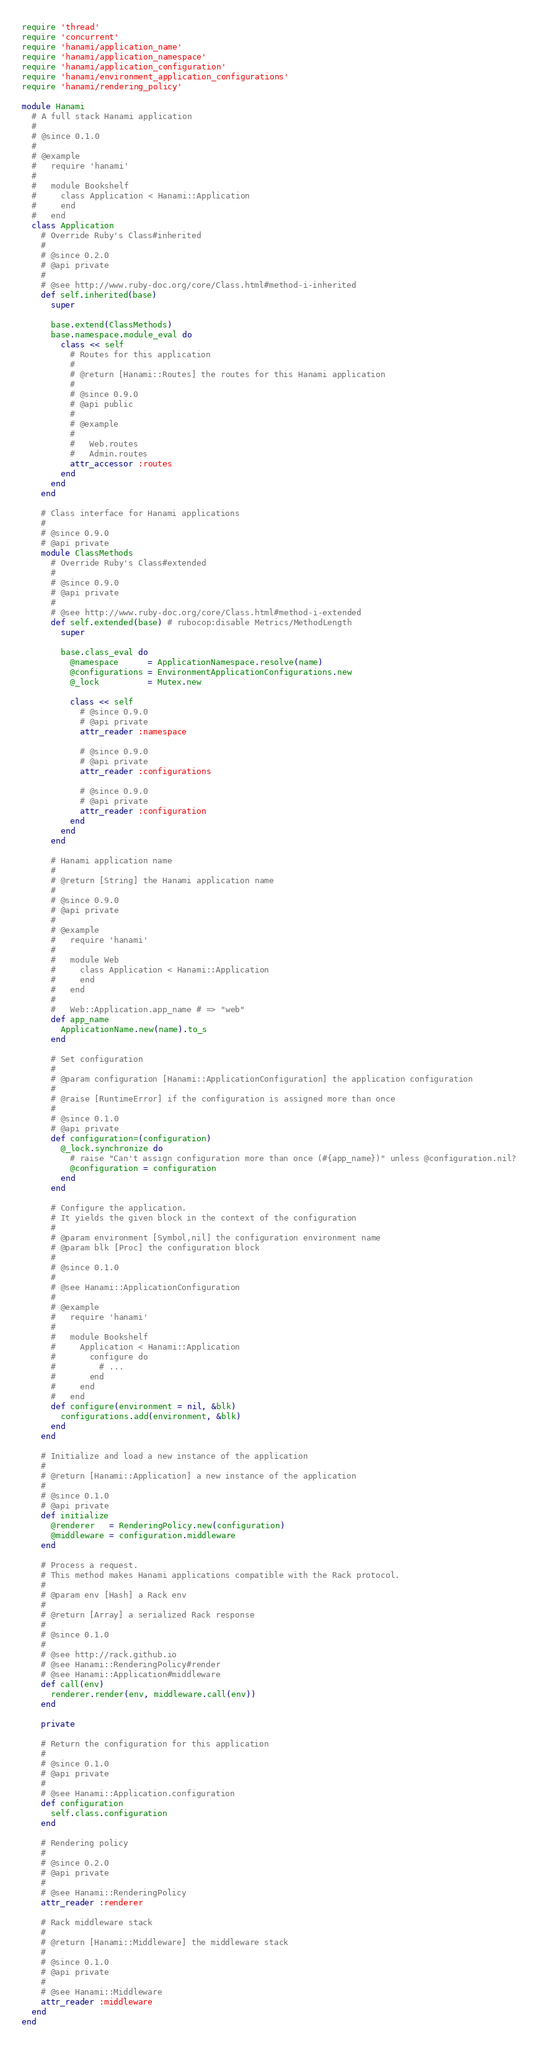Convert code to text. <code><loc_0><loc_0><loc_500><loc_500><_Ruby_>require 'thread'
require 'concurrent'
require 'hanami/application_name'
require 'hanami/application_namespace'
require 'hanami/application_configuration'
require 'hanami/environment_application_configurations'
require 'hanami/rendering_policy'

module Hanami
  # A full stack Hanami application
  #
  # @since 0.1.0
  #
  # @example
  #   require 'hanami'
  #
  #   module Bookshelf
  #     class Application < Hanami::Application
  #     end
  #   end
  class Application
    # Override Ruby's Class#inherited
    #
    # @since 0.2.0
    # @api private
    #
    # @see http://www.ruby-doc.org/core/Class.html#method-i-inherited
    def self.inherited(base)
      super

      base.extend(ClassMethods)
      base.namespace.module_eval do
        class << self
          # Routes for this application
          #
          # @return [Hanami::Routes] the routes for this Hanami application
          #
          # @since 0.9.0
          # @api public
          #
          # @example
          #
          #   Web.routes
          #   Admin.routes
          attr_accessor :routes
        end
      end
    end

    # Class interface for Hanami applications
    #
    # @since 0.9.0
    # @api private
    module ClassMethods
      # Override Ruby's Class#extended
      #
      # @since 0.9.0
      # @api private
      #
      # @see http://www.ruby-doc.org/core/Class.html#method-i-extended
      def self.extended(base) # rubocop:disable Metrics/MethodLength
        super

        base.class_eval do
          @namespace      = ApplicationNamespace.resolve(name)
          @configurations = EnvironmentApplicationConfigurations.new
          @_lock          = Mutex.new

          class << self
            # @since 0.9.0
            # @api private
            attr_reader :namespace

            # @since 0.9.0
            # @api private
            attr_reader :configurations

            # @since 0.9.0
            # @api private
            attr_reader :configuration
          end
        end
      end

      # Hanami application name
      #
      # @return [String] the Hanami application name
      #
      # @since 0.9.0
      # @api private
      #
      # @example
      #   require 'hanami'
      #
      #   module Web
      #     class Application < Hanami::Application
      #     end
      #   end
      #
      #   Web::Application.app_name # => "web"
      def app_name
        ApplicationName.new(name).to_s
      end

      # Set configuration
      #
      # @param configuration [Hanami::ApplicationConfiguration] the application configuration
      #
      # @raise [RuntimeError] if the configuration is assigned more than once
      #
      # @since 0.1.0
      # @api private
      def configuration=(configuration)
        @_lock.synchronize do
          # raise "Can't assign configuration more than once (#{app_name})" unless @configuration.nil?
          @configuration = configuration
        end
      end

      # Configure the application.
      # It yields the given block in the context of the configuration
      #
      # @param environment [Symbol,nil] the configuration environment name
      # @param blk [Proc] the configuration block
      #
      # @since 0.1.0
      #
      # @see Hanami::ApplicationConfiguration
      #
      # @example
      #   require 'hanami'
      #
      #   module Bookshelf
      #     Application < Hanami::Application
      #       configure do
      #         # ...
      #       end
      #     end
      #   end
      def configure(environment = nil, &blk)
        configurations.add(environment, &blk)
      end
    end

    # Initialize and load a new instance of the application
    #
    # @return [Hanami::Application] a new instance of the application
    #
    # @since 0.1.0
    # @api private
    def initialize
      @renderer   = RenderingPolicy.new(configuration)
      @middleware = configuration.middleware
    end

    # Process a request.
    # This method makes Hanami applications compatible with the Rack protocol.
    #
    # @param env [Hash] a Rack env
    #
    # @return [Array] a serialized Rack response
    #
    # @since 0.1.0
    #
    # @see http://rack.github.io
    # @see Hanami::RenderingPolicy#render
    # @see Hanami::Application#middleware
    def call(env)
      renderer.render(env, middleware.call(env))
    end

    private

    # Return the configuration for this application
    #
    # @since 0.1.0
    # @api private
    #
    # @see Hanami::Application.configuration
    def configuration
      self.class.configuration
    end

    # Rendering policy
    #
    # @since 0.2.0
    # @api private
    #
    # @see Hanami::RenderingPolicy
    attr_reader :renderer

    # Rack middleware stack
    #
    # @return [Hanami::Middleware] the middleware stack
    #
    # @since 0.1.0
    # @api private
    #
    # @see Hanami::Middleware
    attr_reader :middleware
  end
end
</code> 